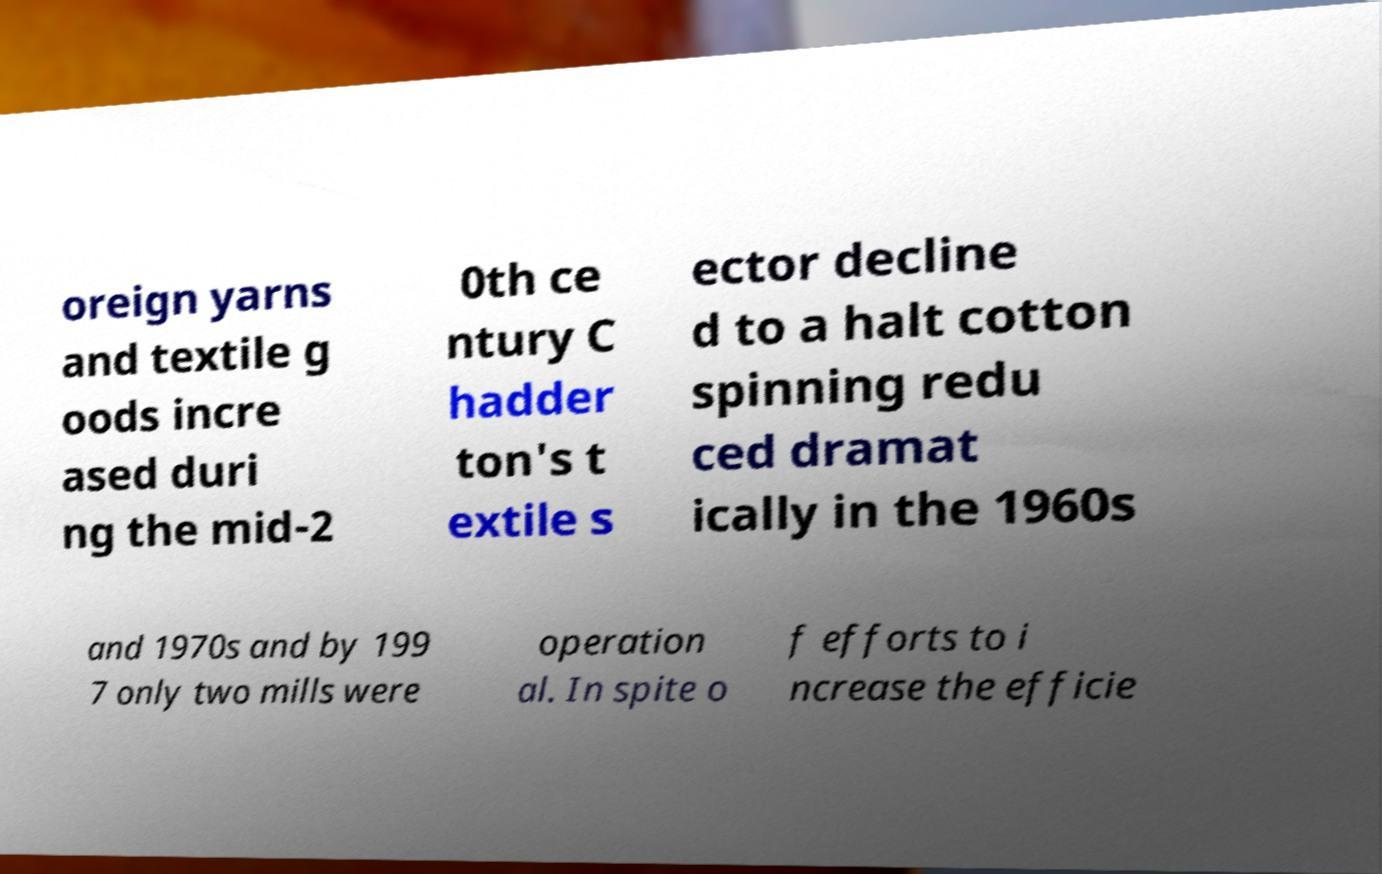Please read and relay the text visible in this image. What does it say? oreign yarns and textile g oods incre ased duri ng the mid-2 0th ce ntury C hadder ton's t extile s ector decline d to a halt cotton spinning redu ced dramat ically in the 1960s and 1970s and by 199 7 only two mills were operation al. In spite o f efforts to i ncrease the efficie 